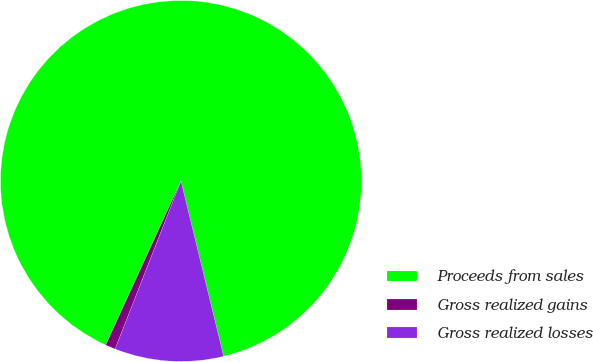Convert chart to OTSL. <chart><loc_0><loc_0><loc_500><loc_500><pie_chart><fcel>Proceeds from sales<fcel>Gross realized gains<fcel>Gross realized losses<nl><fcel>89.35%<fcel>0.9%<fcel>9.75%<nl></chart> 